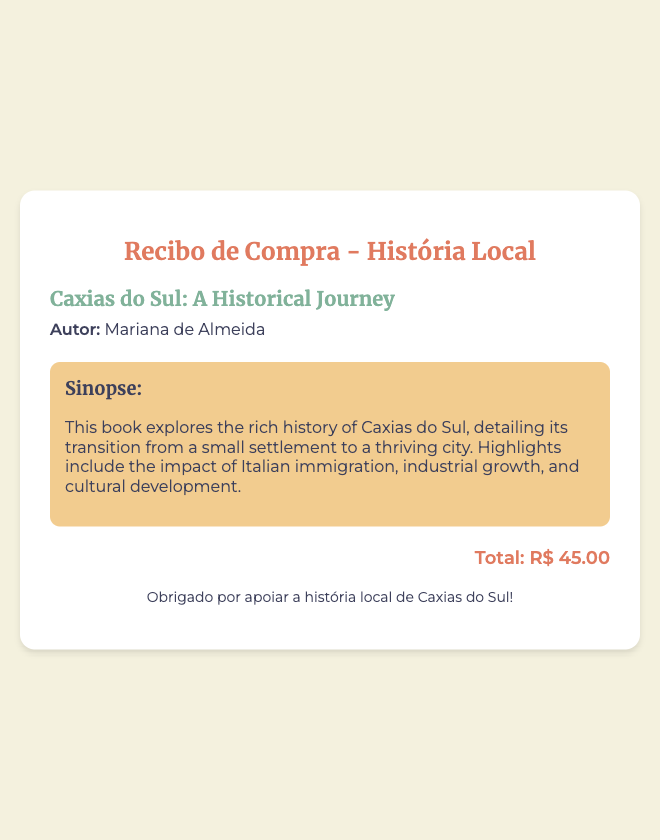What is the title of the book? The title can be found in the book information section, which identifies the specific work being purchased.
Answer: Caxias do Sul: A Historical Journey Who is the author of the book? The author's name is clearly stated alongside the book title in the document.
Answer: Mariana de Almeida What is the total cost of the book? The total cost is specified prominently in the receipt section, clearly indicating how much has been spent.
Answer: R$ 45.00 What historical aspect does the book primarily explore? The synopsis provides a brief overview of the main theme and content of the book.
Answer: Rich history of Caxias do Sul Which immigrant group's impact is highlighted in the book? The synopsis mentions a specific immigrant group that contributed to the city's development.
Answer: Italian immigrants How does the book describe the city's transition? The synopsis captures key details about the transformation of Caxias do Sul from a small settlement.
Answer: From a small settlement to a thriving city What is the purpose of this receipt? The receipt serves to acknowledge the purchase transaction of the book focused on local history.
Answer: Acknowledgment of purchase What does the footer express? The footer typically concludes the receipt with a note of gratitude or appreciation for the purchase.
Answer: Thank you for supporting the local history of Caxias do Sul! 